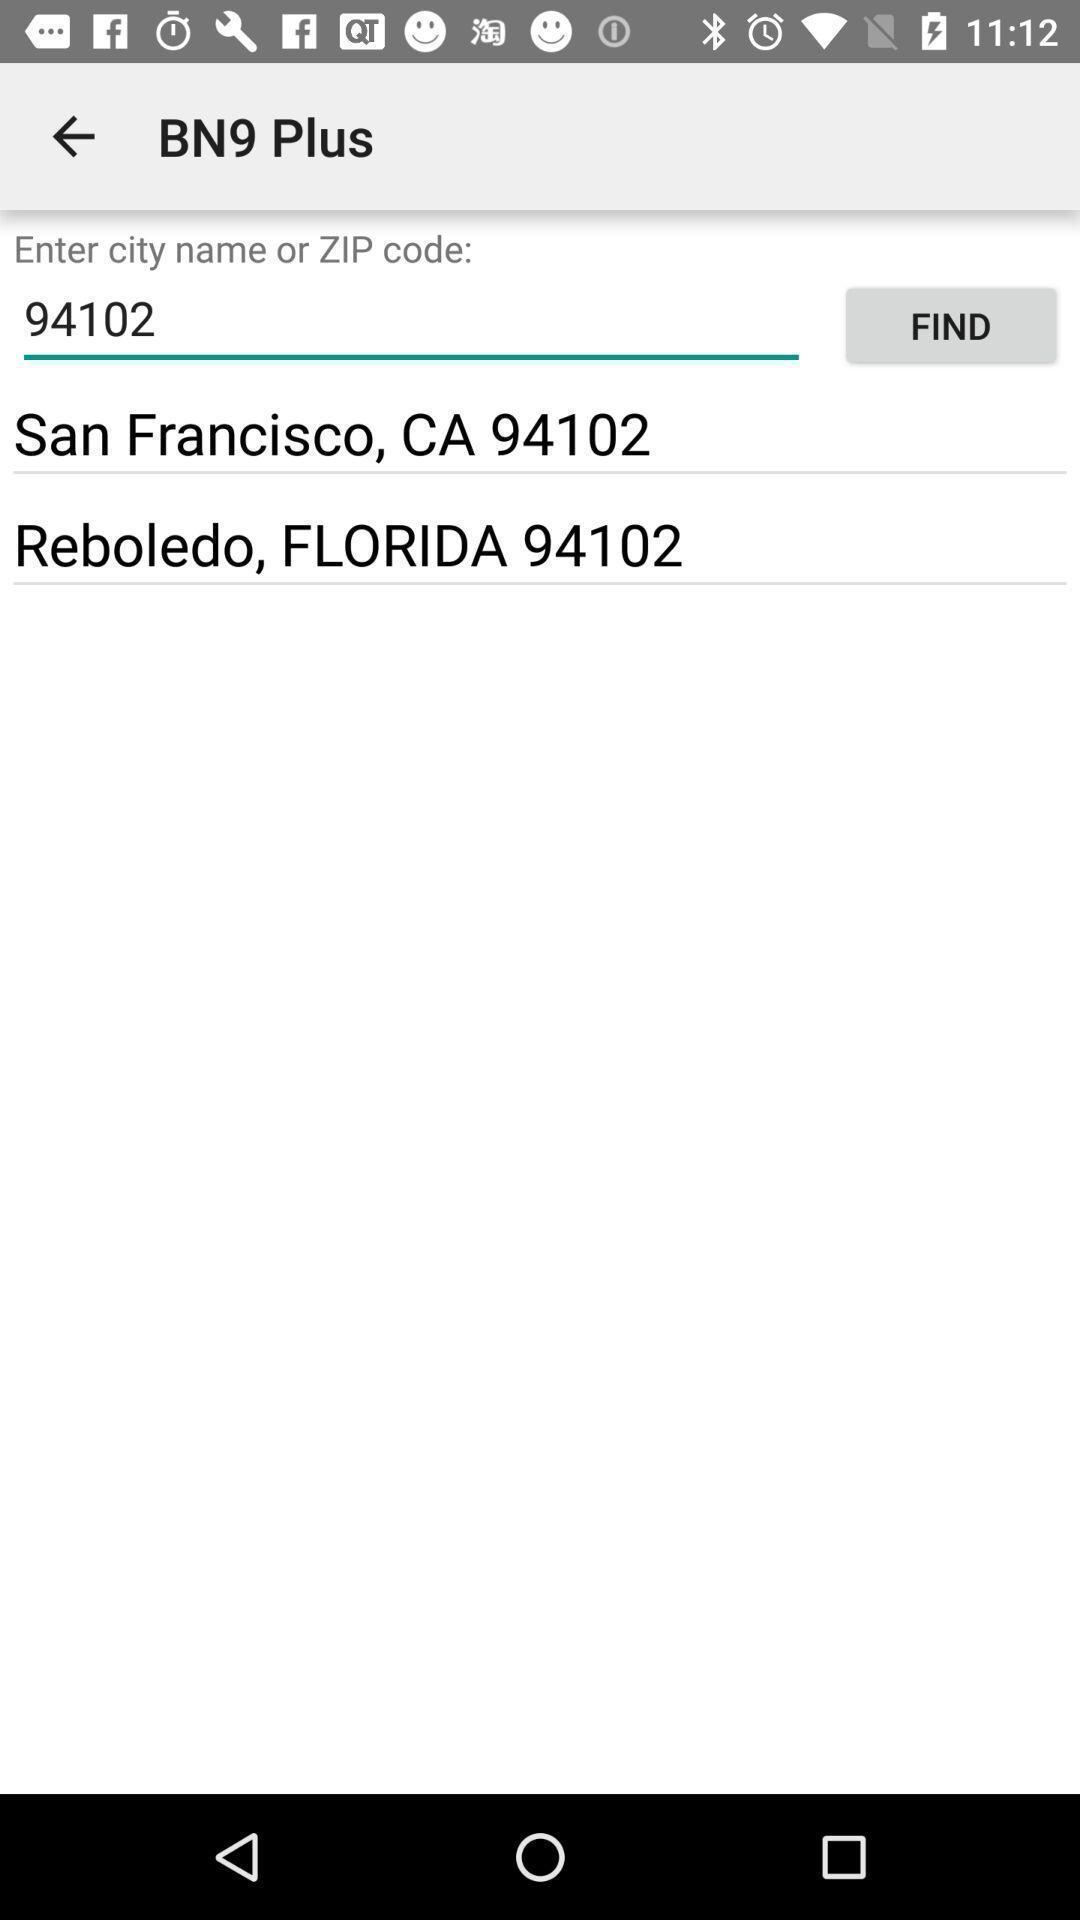Provide a textual representation of this image. Window displaying a news app. 